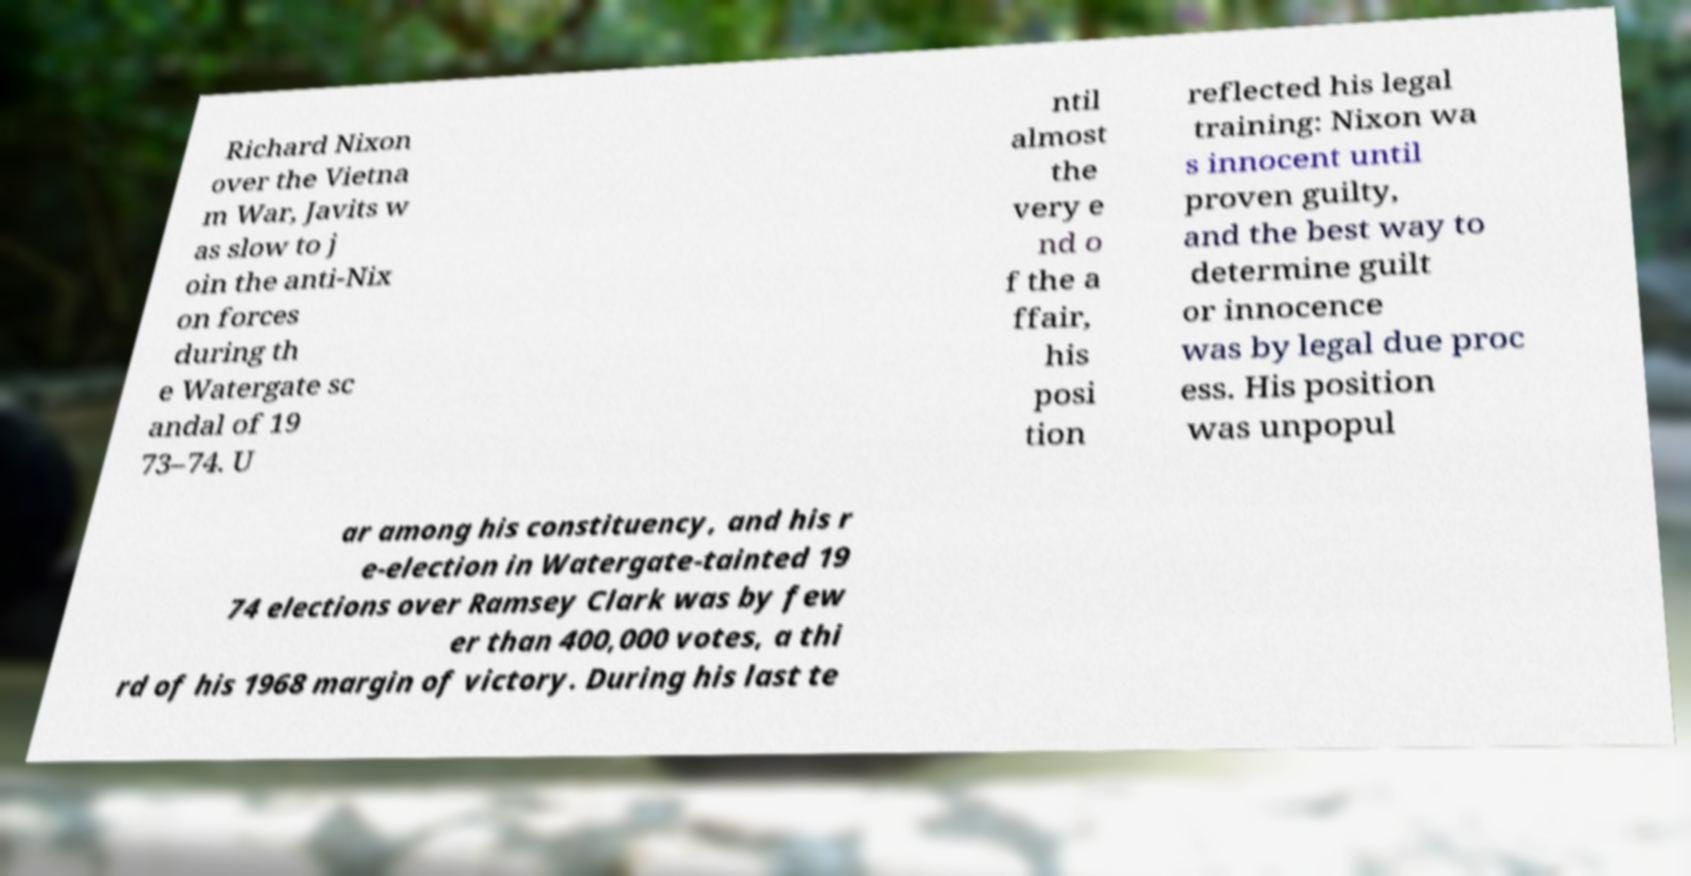Could you assist in decoding the text presented in this image and type it out clearly? Richard Nixon over the Vietna m War, Javits w as slow to j oin the anti-Nix on forces during th e Watergate sc andal of 19 73–74. U ntil almost the very e nd o f the a ffair, his posi tion reflected his legal training: Nixon wa s innocent until proven guilty, and the best way to determine guilt or innocence was by legal due proc ess. His position was unpopul ar among his constituency, and his r e-election in Watergate-tainted 19 74 elections over Ramsey Clark was by few er than 400,000 votes, a thi rd of his 1968 margin of victory. During his last te 